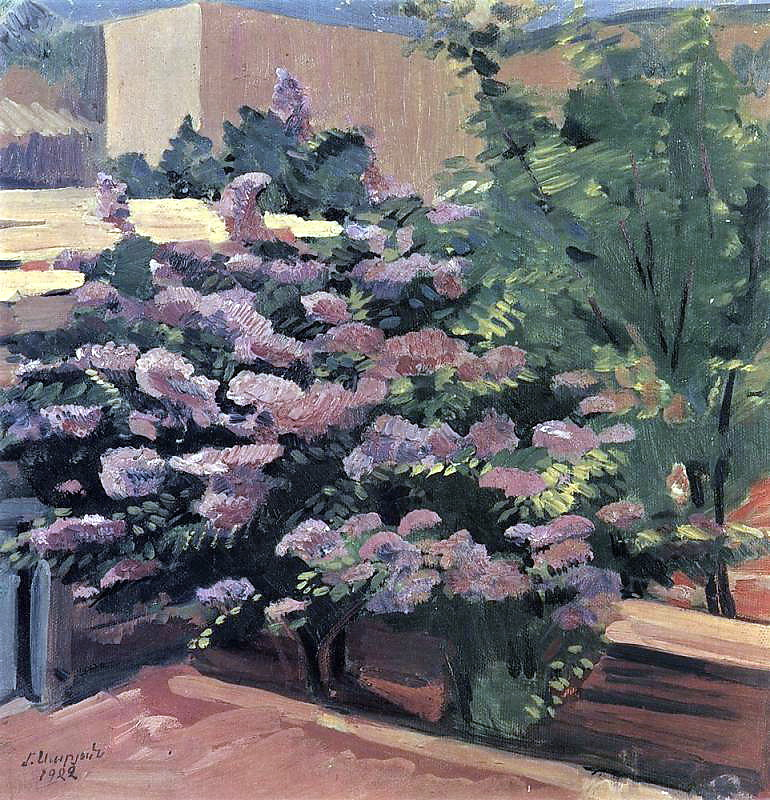Imagine being in this garden. What would it feel, sound, and smell like? Imagine standing in this tranquil garden, surrounded by the delicate fragrance of blooming flowers that fills the air. The soft rustling of leaves as a gentle breeze passes through adds a soothing soundtrack to your surroundings. The vibrant colors of the pink and purple flowers draw your eyes, while the lush green foliage provides a sense of cool, refreshing shade. The mellow sunlight filters through the trees, casting dappled shadows on the ground. It feels like a perfect retreat from the hustle and bustle of daily life, where you can breathe deeply and find peace in the natural beauty around you. What might you see if you looked closely at the flowers in the bush? Upon closer inspection, you would notice the delicate petals of the flowers, each with subtle variations in shades of pink and purple. The petals might have fine veins and a soft texture, with droplets of morning dew gently clinging to them. Tiny insects, such as bees and butterflies, could be seen flitting from bloom to bloom, attracted by the sweet nectar. The leaves of the bush would reveal intricate patterns of veins and a rich green hue, their edges slightly serrated. The overall texture would be a dynamic mix of softness from the petals and the more rigid structure of the stems and leaves. If the garden could tell a story, what story would it share? The garden might share a story of seasons, each bringing its own unique charm and challenges. It would speak of the springtime when it bursts into life with vibrant blooms, the flowers attracting various pollinators that bring life to its branches. Summer would be a time of growth and abundance, with the garden basking in the long hours of sunlight. The tale of autumn would be one of transformation, as the leaves turn golden and the flowers begin to fade, preparing for the rest of winter. Throughout these changes, the garden would tell of quiet moments shared with visitors who find solace in its beauty, each one leaving with a sense of peace and a connection to nature's timeless cycle. 